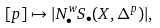Convert formula to latex. <formula><loc_0><loc_0><loc_500><loc_500>[ p ] \mapsto | N ^ { w } _ { \bullet } S _ { \bullet } ( X , \Delta ^ { p } ) | ,</formula> 